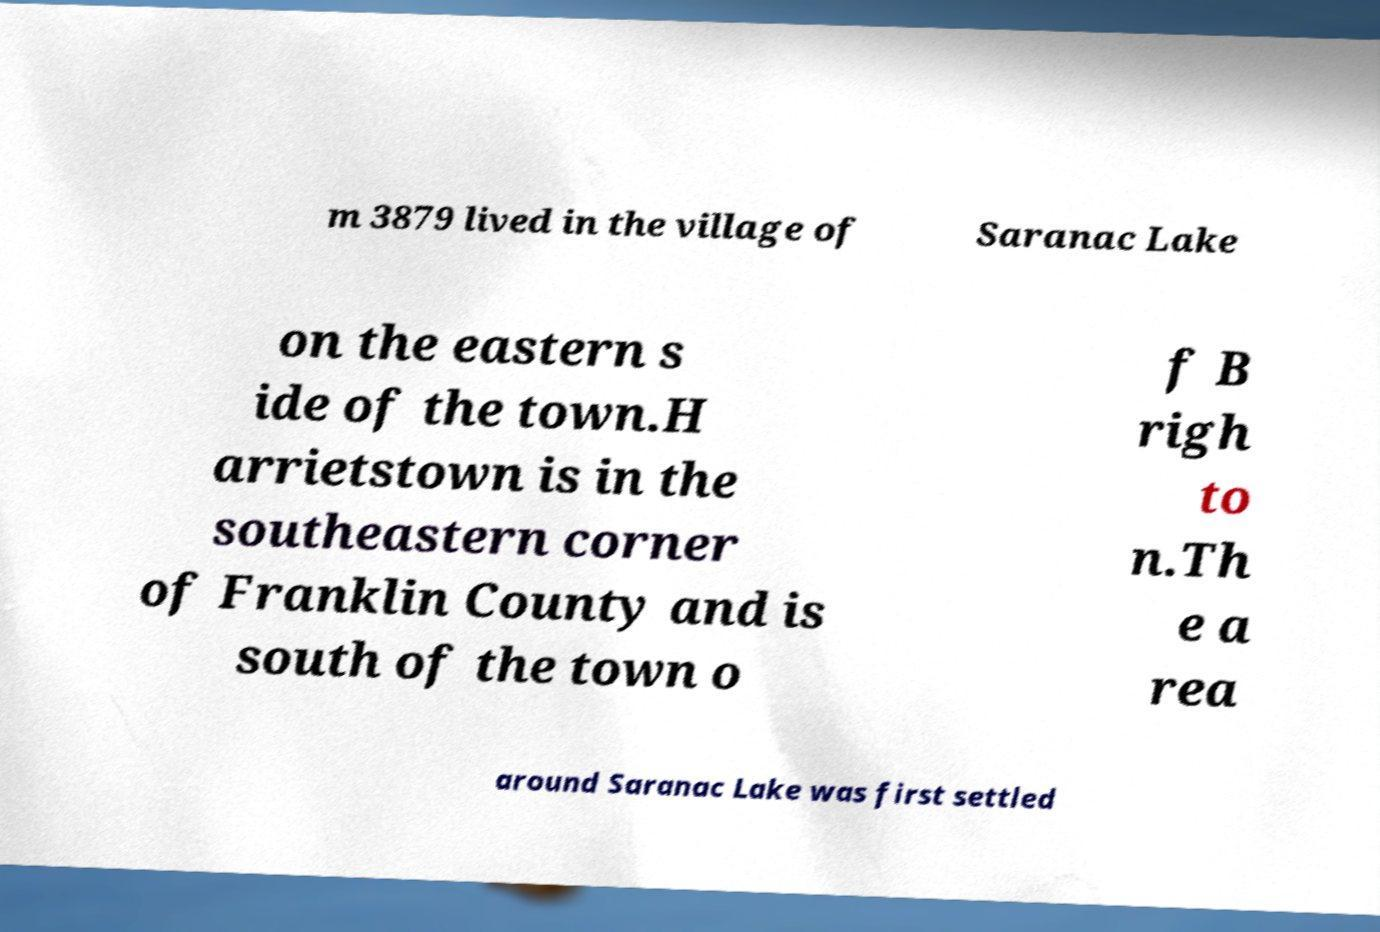For documentation purposes, I need the text within this image transcribed. Could you provide that? m 3879 lived in the village of Saranac Lake on the eastern s ide of the town.H arrietstown is in the southeastern corner of Franklin County and is south of the town o f B righ to n.Th e a rea around Saranac Lake was first settled 